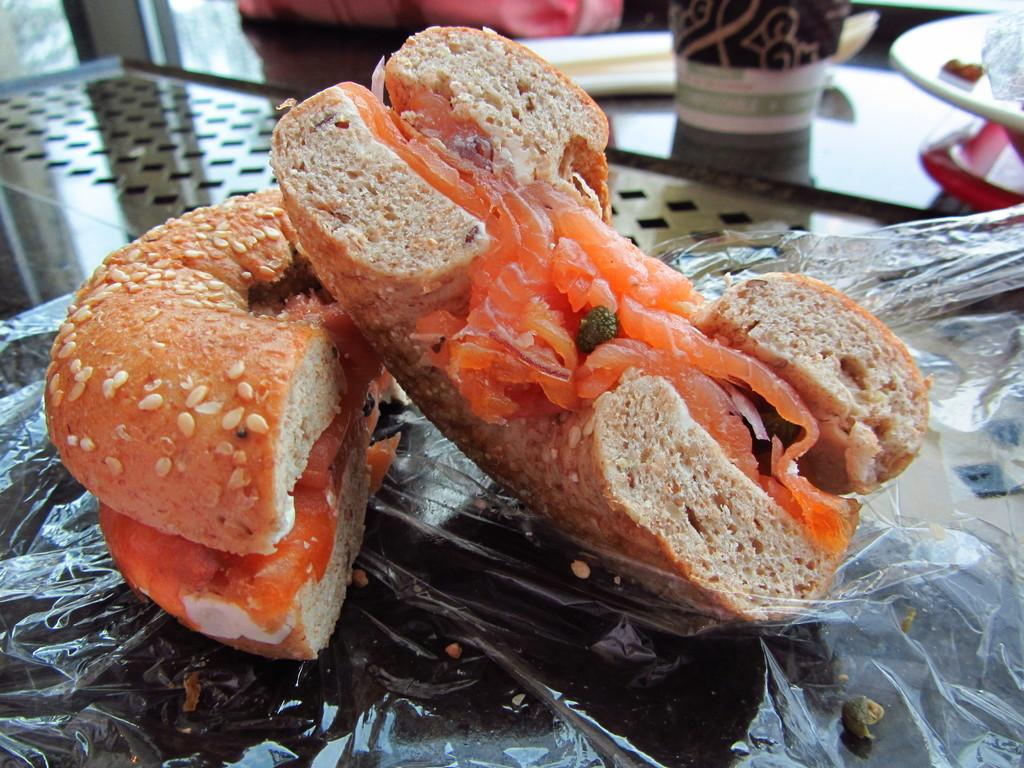What is the main object in the center of the image? There is a table in the center of the image. What is placed on the table? There is a bag, a glass, a plate, a plastic cover, food items, and a few other objects on the table. Can you describe the food items on the table? The food items on the table are not specified, but they are present. How many grapes are on the board in the image? There is no board or grapes present in the image. Does the existence of the table in the image prove the existence of the universe? The existence of the table in the image does not prove the existence of the universe, as the table is a small part of a larger reality. 